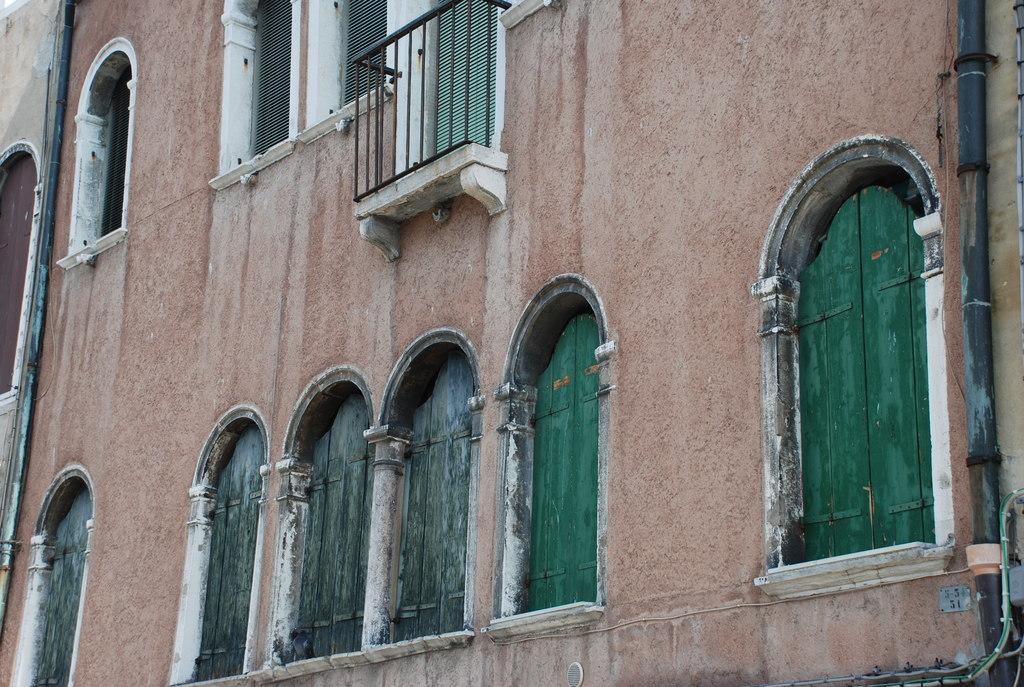Describe this image in one or two sentences. This is a zoom in picture of a building as we can see there are some windows in the bottom of this image and on the top of this image as well. 